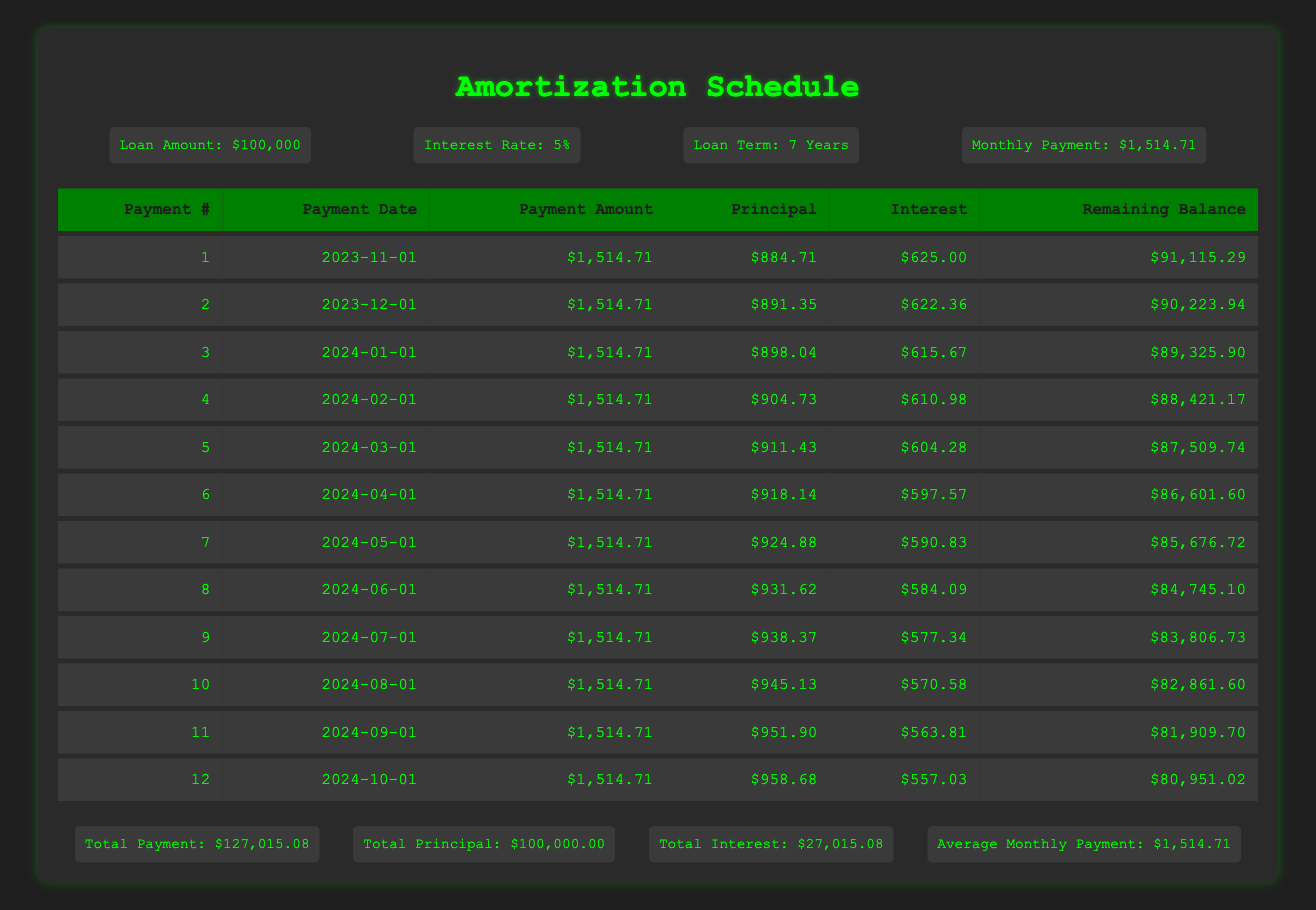What is the total principal paid by the end of the loan term? The total principal is listed in the summary section of the table, which shows "Total Principal: $100,000.00." This means that the full principal amount of the loan is paid off by the end of the loan term.
Answer: 100,000.00 What is the monthly payment amount? The monthly payment amount is shown in the loan details section of the table as "$1,514.71." This is a fixed amount that will be paid each month over the loan term.
Answer: 1,514.71 How much interest is paid in the first payment? In the first payment row, the "Interest" column shows "$625.00." This is the amount of interest paid during the first payment, according to the schedule.
Answer: 625.00 What is the remaining balance after the second payment? The table provides the remaining balance for each payment. After the second payment, the "Remaining Balance" column shows "$90,223.94." This is the amount left to pay after the second payment is made.
Answer: 90,223.94 What is the average monthly payment over the loan term? From the summary, the average monthly payment is given as "$1,514.71." Since the monthly payment is constant, this is the same for each month, and thus also the average.
Answer: 1,514.71 Is the total interest paid greater than the total principal paid? The summary shows "Total Interest: $27,015.08" and "Total Principal: $100,000.00." Since $27,015.08 is less than $100,000.00, the statement is false.
Answer: No What is the total amount paid by the end of the loan term? The summary provides the total payment as "$127,015.08." This value represents the sum of all monthly payments made over the entire loan term.
Answer: 127,015.08 How much does the principal payment increase over the first four months? To find the increase, calculate the difference between the principal payments of months 1 and 4: $904.73 (month 4) - $884.71 (month 1) = $20.02. This shows how much more principal is paid in the fourth month compared to the first.
Answer: 20.02 What is the remaining balance after the first year? After 12 months, the remaining balance is shown after the last recorded payment in the table. Taking the balance from the 12th month, it shows "$80,951.02". This indicates the amount left after one year of payments.
Answer: 80,951.02 